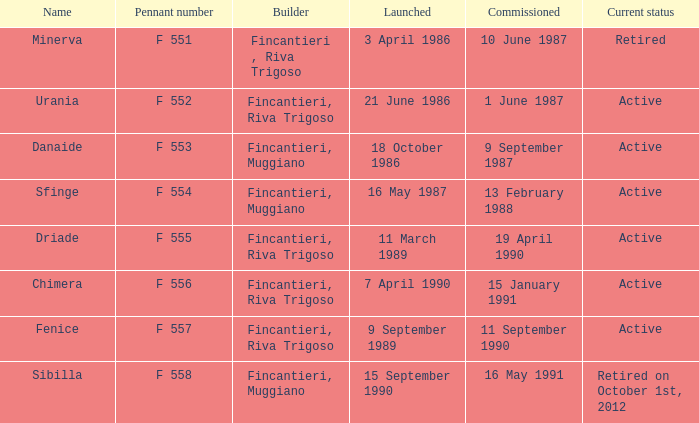Which builder unveiled the name minerva? 3 April 1986. 